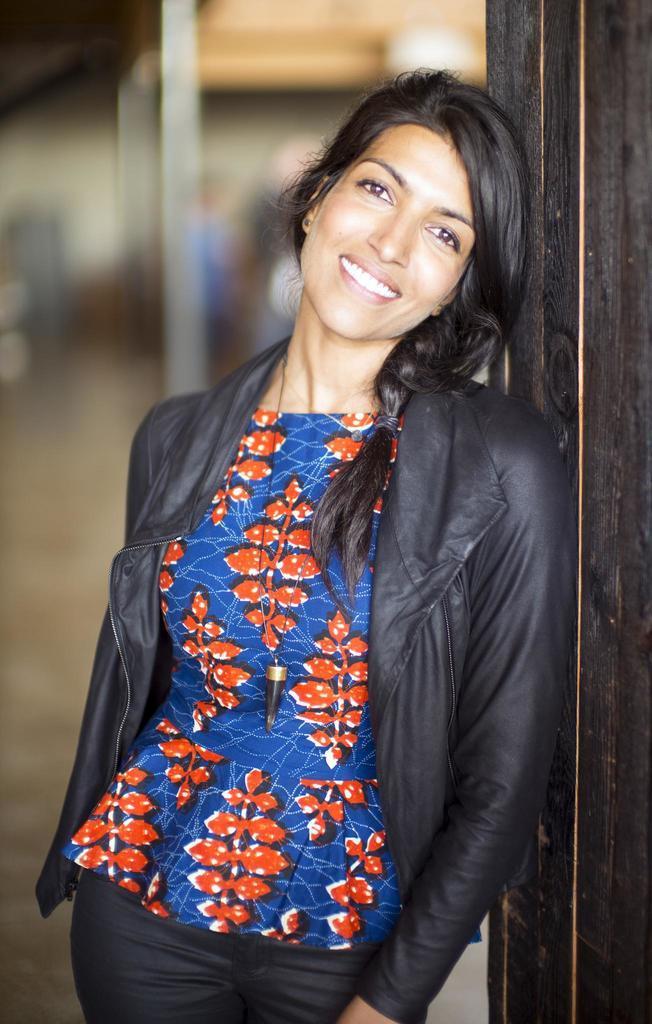Could you give a brief overview of what you see in this image? In this image I can see a woman is standing, I can see smile on her face. I can see she is wearing black jacket, black pant and blue top. I can also see this image is blurry from background. 